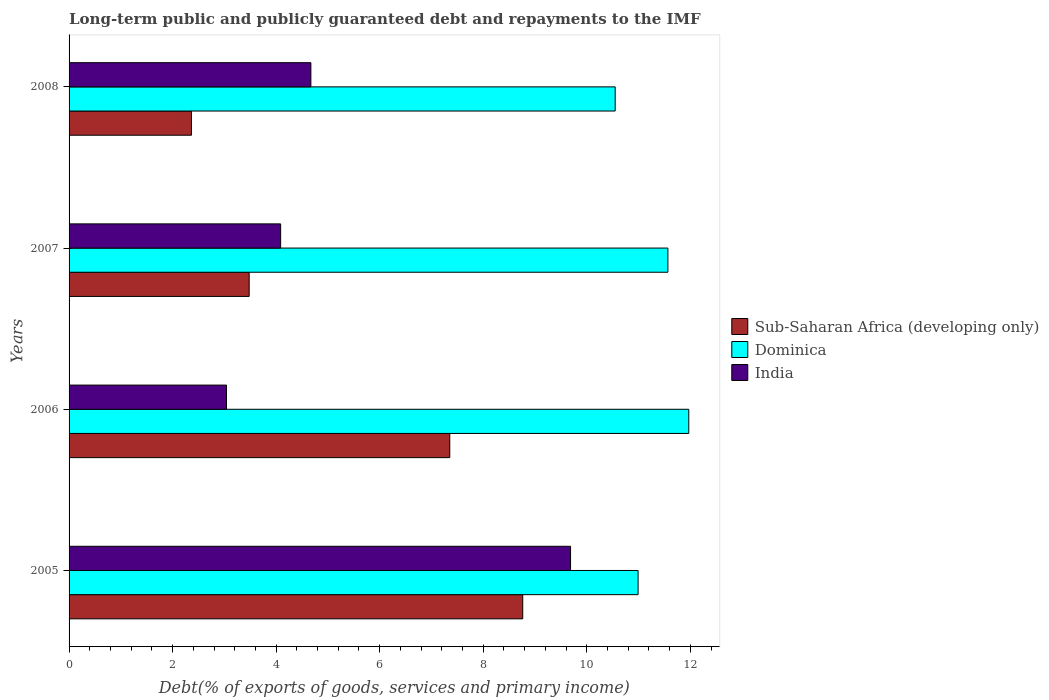How many groups of bars are there?
Your answer should be very brief. 4. Are the number of bars on each tick of the Y-axis equal?
Make the answer very short. Yes. How many bars are there on the 1st tick from the bottom?
Your answer should be compact. 3. What is the label of the 2nd group of bars from the top?
Offer a terse response. 2007. In how many cases, is the number of bars for a given year not equal to the number of legend labels?
Your answer should be compact. 0. What is the debt and repayments in India in 2008?
Provide a succinct answer. 4.67. Across all years, what is the maximum debt and repayments in India?
Give a very brief answer. 9.69. Across all years, what is the minimum debt and repayments in Sub-Saharan Africa (developing only)?
Your response must be concise. 2.36. In which year was the debt and repayments in India maximum?
Offer a terse response. 2005. In which year was the debt and repayments in Sub-Saharan Africa (developing only) minimum?
Your response must be concise. 2008. What is the total debt and repayments in Sub-Saharan Africa (developing only) in the graph?
Offer a terse response. 21.96. What is the difference between the debt and repayments in Sub-Saharan Africa (developing only) in 2006 and that in 2007?
Give a very brief answer. 3.88. What is the difference between the debt and repayments in India in 2008 and the debt and repayments in Dominica in 2007?
Provide a succinct answer. -6.9. What is the average debt and repayments in India per year?
Provide a short and direct response. 5.37. In the year 2005, what is the difference between the debt and repayments in Dominica and debt and repayments in India?
Your answer should be compact. 1.31. In how many years, is the debt and repayments in India greater than 4.8 %?
Make the answer very short. 1. What is the ratio of the debt and repayments in India in 2006 to that in 2007?
Offer a terse response. 0.74. Is the difference between the debt and repayments in Dominica in 2006 and 2007 greater than the difference between the debt and repayments in India in 2006 and 2007?
Your response must be concise. Yes. What is the difference between the highest and the second highest debt and repayments in India?
Give a very brief answer. 5.02. What is the difference between the highest and the lowest debt and repayments in Sub-Saharan Africa (developing only)?
Keep it short and to the point. 6.4. In how many years, is the debt and repayments in Dominica greater than the average debt and repayments in Dominica taken over all years?
Give a very brief answer. 2. Is the sum of the debt and repayments in Dominica in 2005 and 2008 greater than the maximum debt and repayments in Sub-Saharan Africa (developing only) across all years?
Keep it short and to the point. Yes. What does the 2nd bar from the top in 2007 represents?
Provide a succinct answer. Dominica. What does the 1st bar from the bottom in 2008 represents?
Give a very brief answer. Sub-Saharan Africa (developing only). Is it the case that in every year, the sum of the debt and repayments in India and debt and repayments in Dominica is greater than the debt and repayments in Sub-Saharan Africa (developing only)?
Your answer should be compact. Yes. How many bars are there?
Provide a short and direct response. 12. What is the difference between two consecutive major ticks on the X-axis?
Your response must be concise. 2. Does the graph contain grids?
Make the answer very short. No. How are the legend labels stacked?
Give a very brief answer. Vertical. What is the title of the graph?
Offer a very short reply. Long-term public and publicly guaranteed debt and repayments to the IMF. What is the label or title of the X-axis?
Ensure brevity in your answer.  Debt(% of exports of goods, services and primary income). What is the label or title of the Y-axis?
Your answer should be very brief. Years. What is the Debt(% of exports of goods, services and primary income) of Sub-Saharan Africa (developing only) in 2005?
Give a very brief answer. 8.76. What is the Debt(% of exports of goods, services and primary income) of Dominica in 2005?
Keep it short and to the point. 10.99. What is the Debt(% of exports of goods, services and primary income) in India in 2005?
Your answer should be very brief. 9.69. What is the Debt(% of exports of goods, services and primary income) in Sub-Saharan Africa (developing only) in 2006?
Keep it short and to the point. 7.35. What is the Debt(% of exports of goods, services and primary income) of Dominica in 2006?
Ensure brevity in your answer.  11.97. What is the Debt(% of exports of goods, services and primary income) of India in 2006?
Make the answer very short. 3.04. What is the Debt(% of exports of goods, services and primary income) in Sub-Saharan Africa (developing only) in 2007?
Your answer should be very brief. 3.48. What is the Debt(% of exports of goods, services and primary income) of Dominica in 2007?
Provide a succinct answer. 11.57. What is the Debt(% of exports of goods, services and primary income) in India in 2007?
Keep it short and to the point. 4.09. What is the Debt(% of exports of goods, services and primary income) in Sub-Saharan Africa (developing only) in 2008?
Give a very brief answer. 2.36. What is the Debt(% of exports of goods, services and primary income) of Dominica in 2008?
Your response must be concise. 10.55. What is the Debt(% of exports of goods, services and primary income) of India in 2008?
Provide a succinct answer. 4.67. Across all years, what is the maximum Debt(% of exports of goods, services and primary income) of Sub-Saharan Africa (developing only)?
Provide a short and direct response. 8.76. Across all years, what is the maximum Debt(% of exports of goods, services and primary income) of Dominica?
Offer a terse response. 11.97. Across all years, what is the maximum Debt(% of exports of goods, services and primary income) of India?
Make the answer very short. 9.69. Across all years, what is the minimum Debt(% of exports of goods, services and primary income) of Sub-Saharan Africa (developing only)?
Provide a succinct answer. 2.36. Across all years, what is the minimum Debt(% of exports of goods, services and primary income) in Dominica?
Give a very brief answer. 10.55. Across all years, what is the minimum Debt(% of exports of goods, services and primary income) of India?
Offer a very short reply. 3.04. What is the total Debt(% of exports of goods, services and primary income) in Sub-Saharan Africa (developing only) in the graph?
Your answer should be compact. 21.96. What is the total Debt(% of exports of goods, services and primary income) in Dominica in the graph?
Offer a terse response. 45.08. What is the total Debt(% of exports of goods, services and primary income) of India in the graph?
Provide a short and direct response. 21.49. What is the difference between the Debt(% of exports of goods, services and primary income) of Sub-Saharan Africa (developing only) in 2005 and that in 2006?
Provide a succinct answer. 1.41. What is the difference between the Debt(% of exports of goods, services and primary income) in Dominica in 2005 and that in 2006?
Provide a short and direct response. -0.98. What is the difference between the Debt(% of exports of goods, services and primary income) of India in 2005 and that in 2006?
Your response must be concise. 6.65. What is the difference between the Debt(% of exports of goods, services and primary income) in Sub-Saharan Africa (developing only) in 2005 and that in 2007?
Offer a very short reply. 5.28. What is the difference between the Debt(% of exports of goods, services and primary income) in Dominica in 2005 and that in 2007?
Give a very brief answer. -0.58. What is the difference between the Debt(% of exports of goods, services and primary income) of Sub-Saharan Africa (developing only) in 2005 and that in 2008?
Give a very brief answer. 6.4. What is the difference between the Debt(% of exports of goods, services and primary income) of Dominica in 2005 and that in 2008?
Offer a very short reply. 0.44. What is the difference between the Debt(% of exports of goods, services and primary income) of India in 2005 and that in 2008?
Provide a short and direct response. 5.02. What is the difference between the Debt(% of exports of goods, services and primary income) in Sub-Saharan Africa (developing only) in 2006 and that in 2007?
Ensure brevity in your answer.  3.88. What is the difference between the Debt(% of exports of goods, services and primary income) of Dominica in 2006 and that in 2007?
Provide a short and direct response. 0.4. What is the difference between the Debt(% of exports of goods, services and primary income) of India in 2006 and that in 2007?
Give a very brief answer. -1.05. What is the difference between the Debt(% of exports of goods, services and primary income) of Sub-Saharan Africa (developing only) in 2006 and that in 2008?
Offer a very short reply. 4.99. What is the difference between the Debt(% of exports of goods, services and primary income) in Dominica in 2006 and that in 2008?
Offer a very short reply. 1.42. What is the difference between the Debt(% of exports of goods, services and primary income) of India in 2006 and that in 2008?
Give a very brief answer. -1.63. What is the difference between the Debt(% of exports of goods, services and primary income) in Sub-Saharan Africa (developing only) in 2007 and that in 2008?
Give a very brief answer. 1.11. What is the difference between the Debt(% of exports of goods, services and primary income) of India in 2007 and that in 2008?
Give a very brief answer. -0.58. What is the difference between the Debt(% of exports of goods, services and primary income) in Sub-Saharan Africa (developing only) in 2005 and the Debt(% of exports of goods, services and primary income) in Dominica in 2006?
Provide a succinct answer. -3.21. What is the difference between the Debt(% of exports of goods, services and primary income) in Sub-Saharan Africa (developing only) in 2005 and the Debt(% of exports of goods, services and primary income) in India in 2006?
Your response must be concise. 5.72. What is the difference between the Debt(% of exports of goods, services and primary income) of Dominica in 2005 and the Debt(% of exports of goods, services and primary income) of India in 2006?
Your response must be concise. 7.95. What is the difference between the Debt(% of exports of goods, services and primary income) of Sub-Saharan Africa (developing only) in 2005 and the Debt(% of exports of goods, services and primary income) of Dominica in 2007?
Offer a terse response. -2.8. What is the difference between the Debt(% of exports of goods, services and primary income) in Sub-Saharan Africa (developing only) in 2005 and the Debt(% of exports of goods, services and primary income) in India in 2007?
Keep it short and to the point. 4.68. What is the difference between the Debt(% of exports of goods, services and primary income) in Dominica in 2005 and the Debt(% of exports of goods, services and primary income) in India in 2007?
Offer a very short reply. 6.91. What is the difference between the Debt(% of exports of goods, services and primary income) in Sub-Saharan Africa (developing only) in 2005 and the Debt(% of exports of goods, services and primary income) in Dominica in 2008?
Offer a terse response. -1.79. What is the difference between the Debt(% of exports of goods, services and primary income) in Sub-Saharan Africa (developing only) in 2005 and the Debt(% of exports of goods, services and primary income) in India in 2008?
Make the answer very short. 4.09. What is the difference between the Debt(% of exports of goods, services and primary income) in Dominica in 2005 and the Debt(% of exports of goods, services and primary income) in India in 2008?
Provide a short and direct response. 6.32. What is the difference between the Debt(% of exports of goods, services and primary income) of Sub-Saharan Africa (developing only) in 2006 and the Debt(% of exports of goods, services and primary income) of Dominica in 2007?
Keep it short and to the point. -4.21. What is the difference between the Debt(% of exports of goods, services and primary income) of Sub-Saharan Africa (developing only) in 2006 and the Debt(% of exports of goods, services and primary income) of India in 2007?
Offer a very short reply. 3.27. What is the difference between the Debt(% of exports of goods, services and primary income) in Dominica in 2006 and the Debt(% of exports of goods, services and primary income) in India in 2007?
Provide a succinct answer. 7.88. What is the difference between the Debt(% of exports of goods, services and primary income) of Sub-Saharan Africa (developing only) in 2006 and the Debt(% of exports of goods, services and primary income) of Dominica in 2008?
Offer a very short reply. -3.2. What is the difference between the Debt(% of exports of goods, services and primary income) of Sub-Saharan Africa (developing only) in 2006 and the Debt(% of exports of goods, services and primary income) of India in 2008?
Keep it short and to the point. 2.68. What is the difference between the Debt(% of exports of goods, services and primary income) in Dominica in 2006 and the Debt(% of exports of goods, services and primary income) in India in 2008?
Your answer should be compact. 7.3. What is the difference between the Debt(% of exports of goods, services and primary income) of Sub-Saharan Africa (developing only) in 2007 and the Debt(% of exports of goods, services and primary income) of Dominica in 2008?
Make the answer very short. -7.07. What is the difference between the Debt(% of exports of goods, services and primary income) of Sub-Saharan Africa (developing only) in 2007 and the Debt(% of exports of goods, services and primary income) of India in 2008?
Keep it short and to the point. -1.19. What is the difference between the Debt(% of exports of goods, services and primary income) of Dominica in 2007 and the Debt(% of exports of goods, services and primary income) of India in 2008?
Keep it short and to the point. 6.9. What is the average Debt(% of exports of goods, services and primary income) of Sub-Saharan Africa (developing only) per year?
Give a very brief answer. 5.49. What is the average Debt(% of exports of goods, services and primary income) of Dominica per year?
Offer a very short reply. 11.27. What is the average Debt(% of exports of goods, services and primary income) in India per year?
Make the answer very short. 5.37. In the year 2005, what is the difference between the Debt(% of exports of goods, services and primary income) in Sub-Saharan Africa (developing only) and Debt(% of exports of goods, services and primary income) in Dominica?
Provide a short and direct response. -2.23. In the year 2005, what is the difference between the Debt(% of exports of goods, services and primary income) of Sub-Saharan Africa (developing only) and Debt(% of exports of goods, services and primary income) of India?
Your answer should be compact. -0.92. In the year 2005, what is the difference between the Debt(% of exports of goods, services and primary income) of Dominica and Debt(% of exports of goods, services and primary income) of India?
Keep it short and to the point. 1.3. In the year 2006, what is the difference between the Debt(% of exports of goods, services and primary income) in Sub-Saharan Africa (developing only) and Debt(% of exports of goods, services and primary income) in Dominica?
Your response must be concise. -4.62. In the year 2006, what is the difference between the Debt(% of exports of goods, services and primary income) of Sub-Saharan Africa (developing only) and Debt(% of exports of goods, services and primary income) of India?
Offer a terse response. 4.31. In the year 2006, what is the difference between the Debt(% of exports of goods, services and primary income) in Dominica and Debt(% of exports of goods, services and primary income) in India?
Ensure brevity in your answer.  8.93. In the year 2007, what is the difference between the Debt(% of exports of goods, services and primary income) of Sub-Saharan Africa (developing only) and Debt(% of exports of goods, services and primary income) of Dominica?
Ensure brevity in your answer.  -8.09. In the year 2007, what is the difference between the Debt(% of exports of goods, services and primary income) of Sub-Saharan Africa (developing only) and Debt(% of exports of goods, services and primary income) of India?
Provide a succinct answer. -0.61. In the year 2007, what is the difference between the Debt(% of exports of goods, services and primary income) of Dominica and Debt(% of exports of goods, services and primary income) of India?
Offer a very short reply. 7.48. In the year 2008, what is the difference between the Debt(% of exports of goods, services and primary income) of Sub-Saharan Africa (developing only) and Debt(% of exports of goods, services and primary income) of Dominica?
Offer a very short reply. -8.18. In the year 2008, what is the difference between the Debt(% of exports of goods, services and primary income) of Sub-Saharan Africa (developing only) and Debt(% of exports of goods, services and primary income) of India?
Offer a very short reply. -2.31. In the year 2008, what is the difference between the Debt(% of exports of goods, services and primary income) of Dominica and Debt(% of exports of goods, services and primary income) of India?
Make the answer very short. 5.88. What is the ratio of the Debt(% of exports of goods, services and primary income) of Sub-Saharan Africa (developing only) in 2005 to that in 2006?
Your answer should be very brief. 1.19. What is the ratio of the Debt(% of exports of goods, services and primary income) in Dominica in 2005 to that in 2006?
Offer a very short reply. 0.92. What is the ratio of the Debt(% of exports of goods, services and primary income) in India in 2005 to that in 2006?
Offer a terse response. 3.19. What is the ratio of the Debt(% of exports of goods, services and primary income) in Sub-Saharan Africa (developing only) in 2005 to that in 2007?
Give a very brief answer. 2.52. What is the ratio of the Debt(% of exports of goods, services and primary income) of Dominica in 2005 to that in 2007?
Keep it short and to the point. 0.95. What is the ratio of the Debt(% of exports of goods, services and primary income) in India in 2005 to that in 2007?
Offer a terse response. 2.37. What is the ratio of the Debt(% of exports of goods, services and primary income) in Sub-Saharan Africa (developing only) in 2005 to that in 2008?
Provide a succinct answer. 3.71. What is the ratio of the Debt(% of exports of goods, services and primary income) of Dominica in 2005 to that in 2008?
Ensure brevity in your answer.  1.04. What is the ratio of the Debt(% of exports of goods, services and primary income) of India in 2005 to that in 2008?
Your response must be concise. 2.07. What is the ratio of the Debt(% of exports of goods, services and primary income) in Sub-Saharan Africa (developing only) in 2006 to that in 2007?
Provide a short and direct response. 2.11. What is the ratio of the Debt(% of exports of goods, services and primary income) of Dominica in 2006 to that in 2007?
Make the answer very short. 1.03. What is the ratio of the Debt(% of exports of goods, services and primary income) in India in 2006 to that in 2007?
Provide a short and direct response. 0.74. What is the ratio of the Debt(% of exports of goods, services and primary income) in Sub-Saharan Africa (developing only) in 2006 to that in 2008?
Keep it short and to the point. 3.11. What is the ratio of the Debt(% of exports of goods, services and primary income) of Dominica in 2006 to that in 2008?
Provide a short and direct response. 1.13. What is the ratio of the Debt(% of exports of goods, services and primary income) of India in 2006 to that in 2008?
Give a very brief answer. 0.65. What is the ratio of the Debt(% of exports of goods, services and primary income) in Sub-Saharan Africa (developing only) in 2007 to that in 2008?
Offer a terse response. 1.47. What is the ratio of the Debt(% of exports of goods, services and primary income) in Dominica in 2007 to that in 2008?
Your answer should be very brief. 1.1. What is the ratio of the Debt(% of exports of goods, services and primary income) of India in 2007 to that in 2008?
Provide a succinct answer. 0.87. What is the difference between the highest and the second highest Debt(% of exports of goods, services and primary income) in Sub-Saharan Africa (developing only)?
Your answer should be very brief. 1.41. What is the difference between the highest and the second highest Debt(% of exports of goods, services and primary income) of Dominica?
Ensure brevity in your answer.  0.4. What is the difference between the highest and the second highest Debt(% of exports of goods, services and primary income) in India?
Give a very brief answer. 5.02. What is the difference between the highest and the lowest Debt(% of exports of goods, services and primary income) of Sub-Saharan Africa (developing only)?
Your response must be concise. 6.4. What is the difference between the highest and the lowest Debt(% of exports of goods, services and primary income) of Dominica?
Your answer should be compact. 1.42. What is the difference between the highest and the lowest Debt(% of exports of goods, services and primary income) in India?
Give a very brief answer. 6.65. 